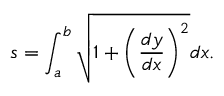<formula> <loc_0><loc_0><loc_500><loc_500>s = \int _ { a } ^ { b } { \sqrt { 1 + \left ( { \frac { d y } { d x } } \right ) ^ { 2 } } } d x .</formula> 